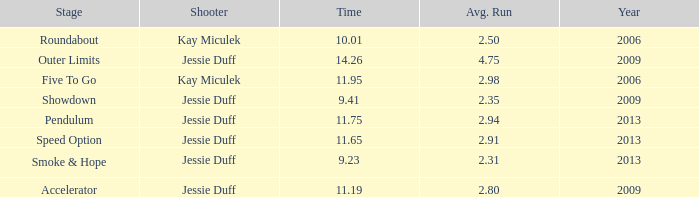What is the total amount of time for years prior to 2013 when speed option is the stage? None. 